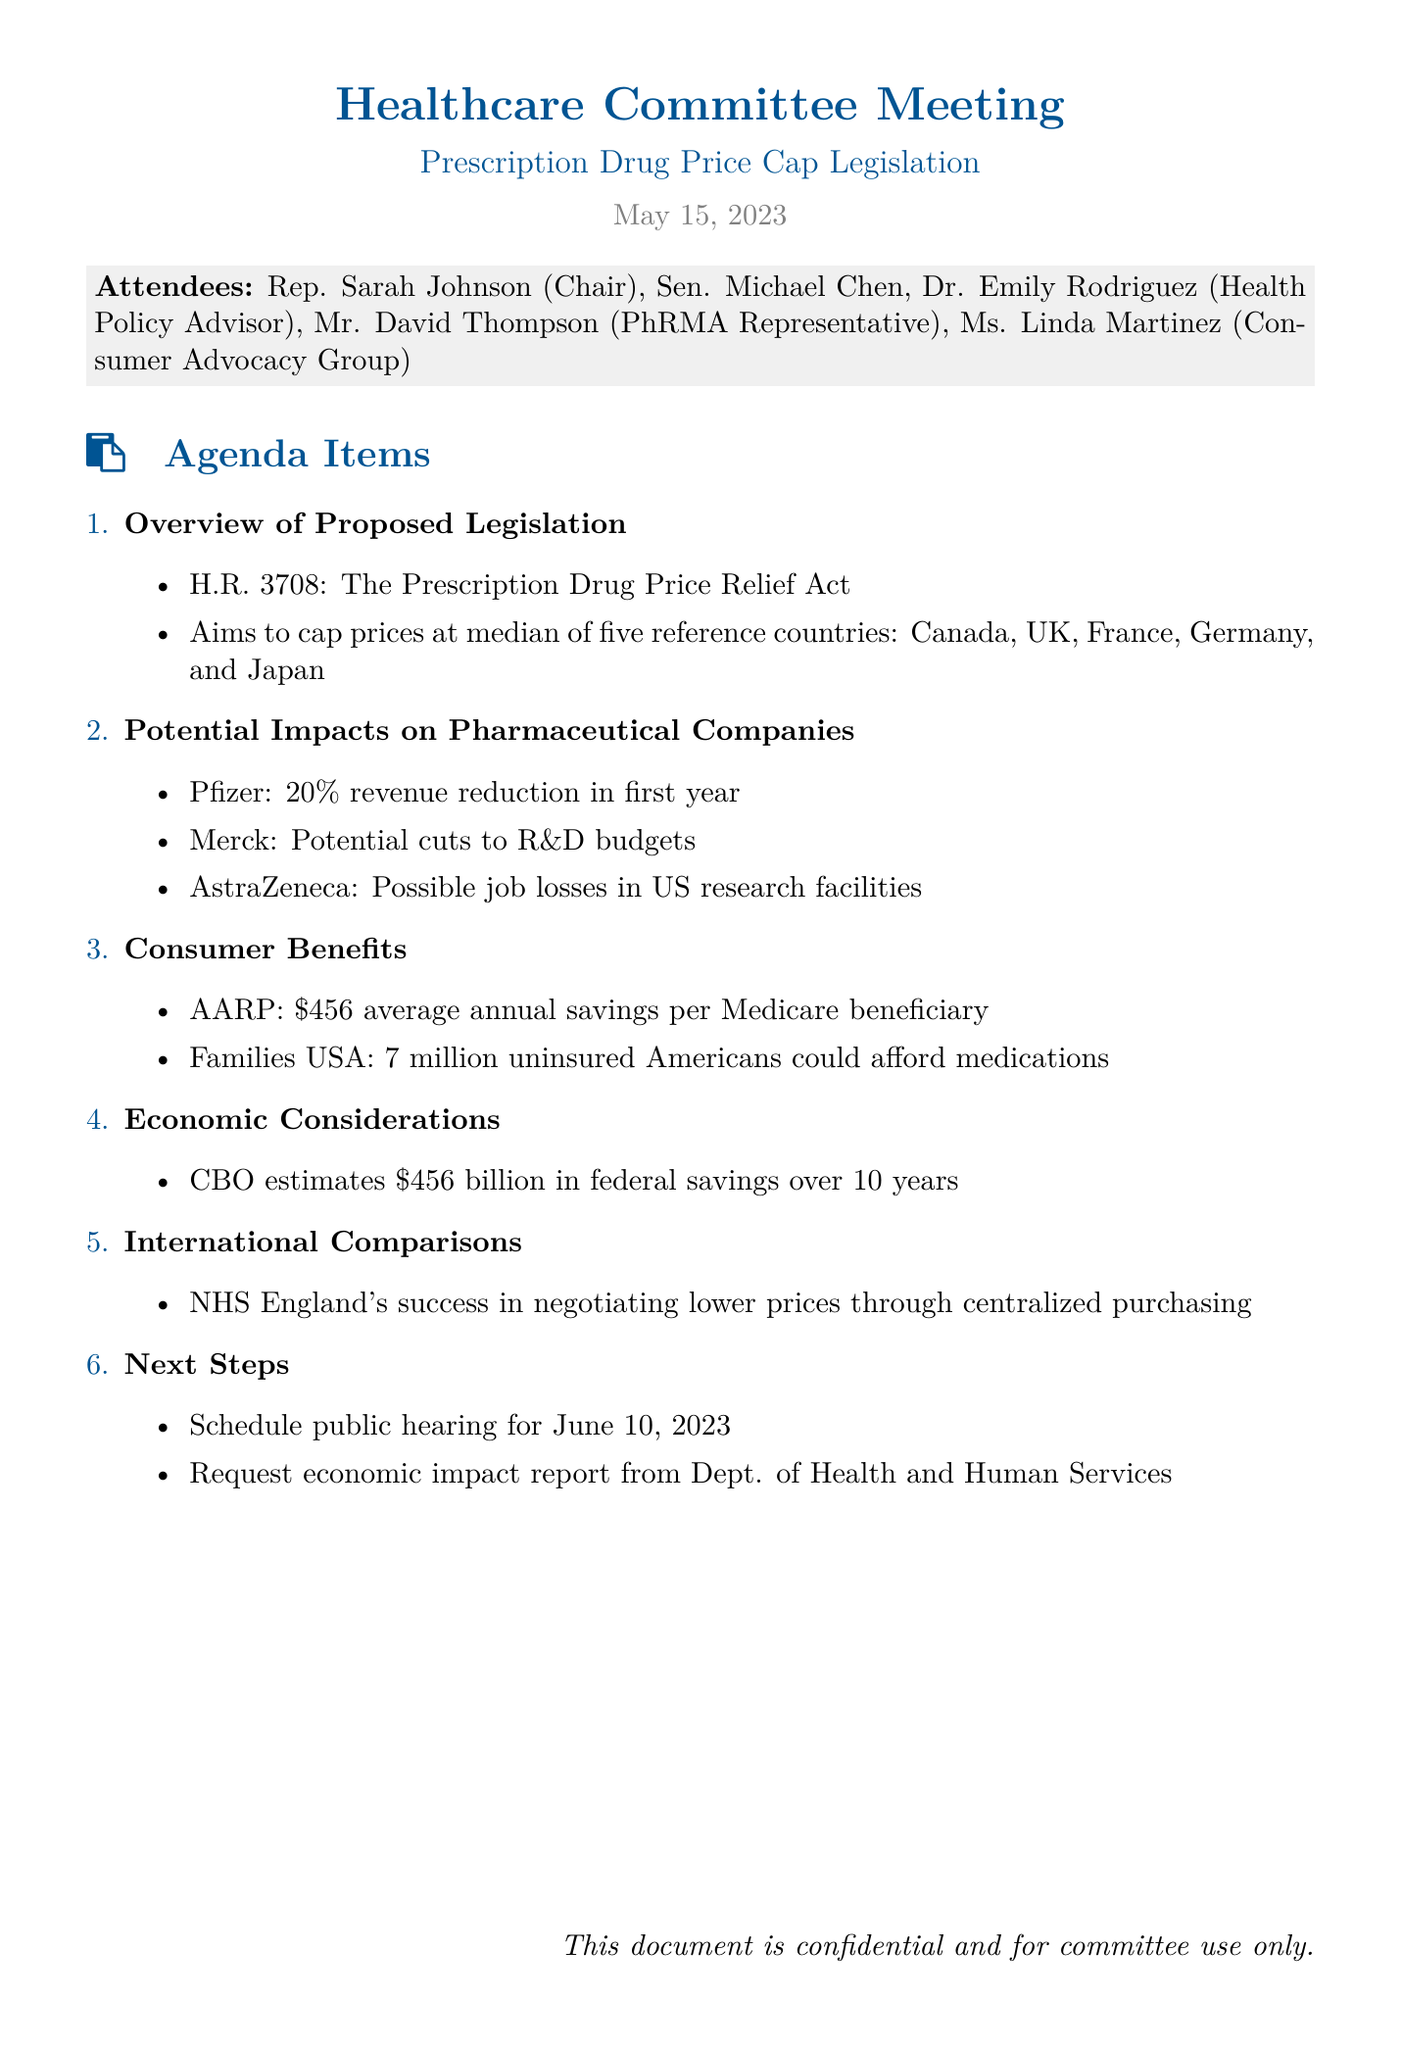What is the title of the proposed legislation? The title of the proposed legislation is mentioned in the overview section of the document as H.R. 3708.
Answer: H.R. 3708 What average annual savings does AARP project for Medicare beneficiaries? The average annual savings project by AARP is specifically listed in the consumer benefits section of the document.
Answer: $456 What are the five reference countries for drug price capping? The five reference countries for drug price capping are listed under the overview of proposed legislation.
Answer: Canada, UK, France, Germany, Japan What potential impact on revenue does Pfizer estimate if the bill passes? Pfizer's estimated impact on revenue is detailed in the potential impacts section.
Answer: 20% How many uninsured Americans could afford medications according to Families USA? The number of uninsured Americans stated by Families USA can be found in the consumer benefits section.
Answer: 7 million What is the total estimated federal savings over 10 years by the Congressional Budget Office? The total estimated federal savings can be found in the economic considerations section.
Answer: $456 billion What is the scheduled date for the public hearing? The scheduled date for the public hearing is mentioned in the next steps section.
Answer: June 10, 2023 Who represents the Consumer Advocacy Group in this meeting? The representative for the Consumer Advocacy Group is listed among the attendees.
Answer: Ms. Linda Martinez 